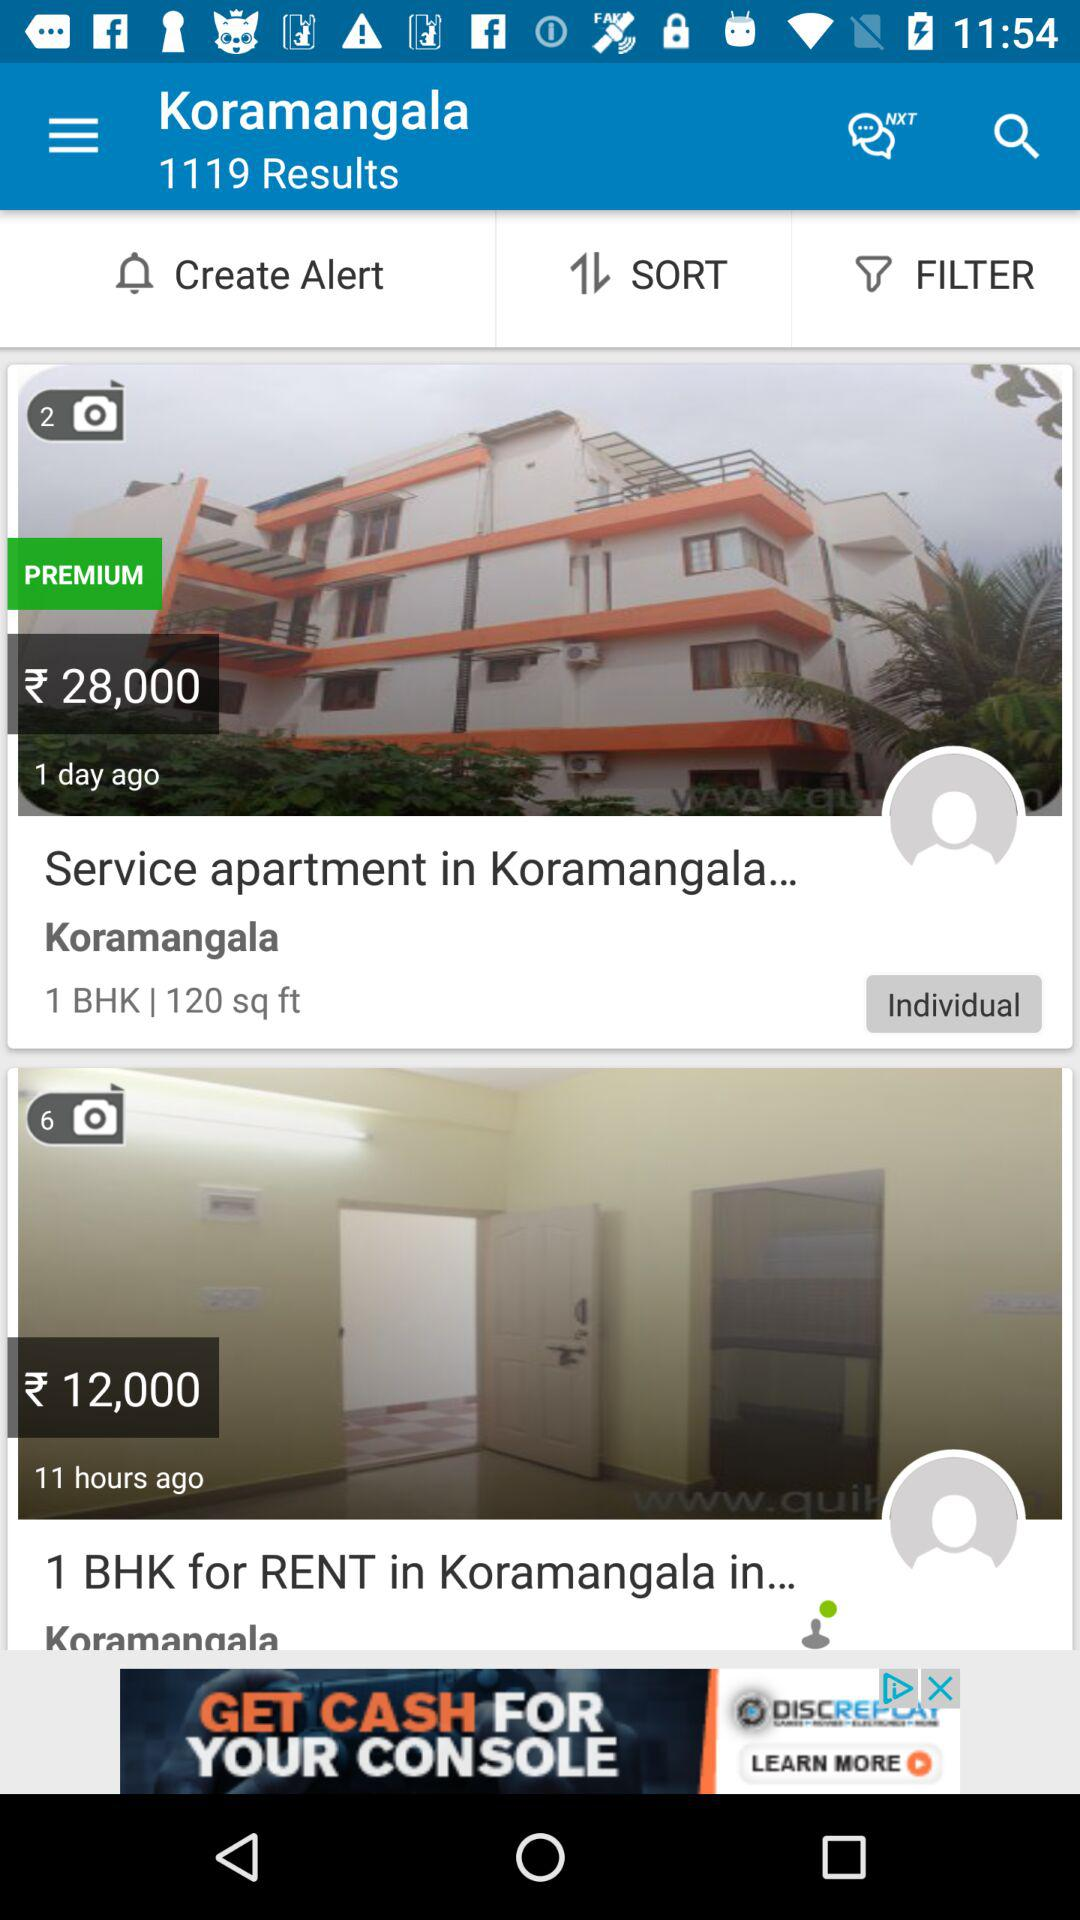Which apartment is in the premium category? The apartment that is in the premium category is "Service apartment in Koramangala...". 